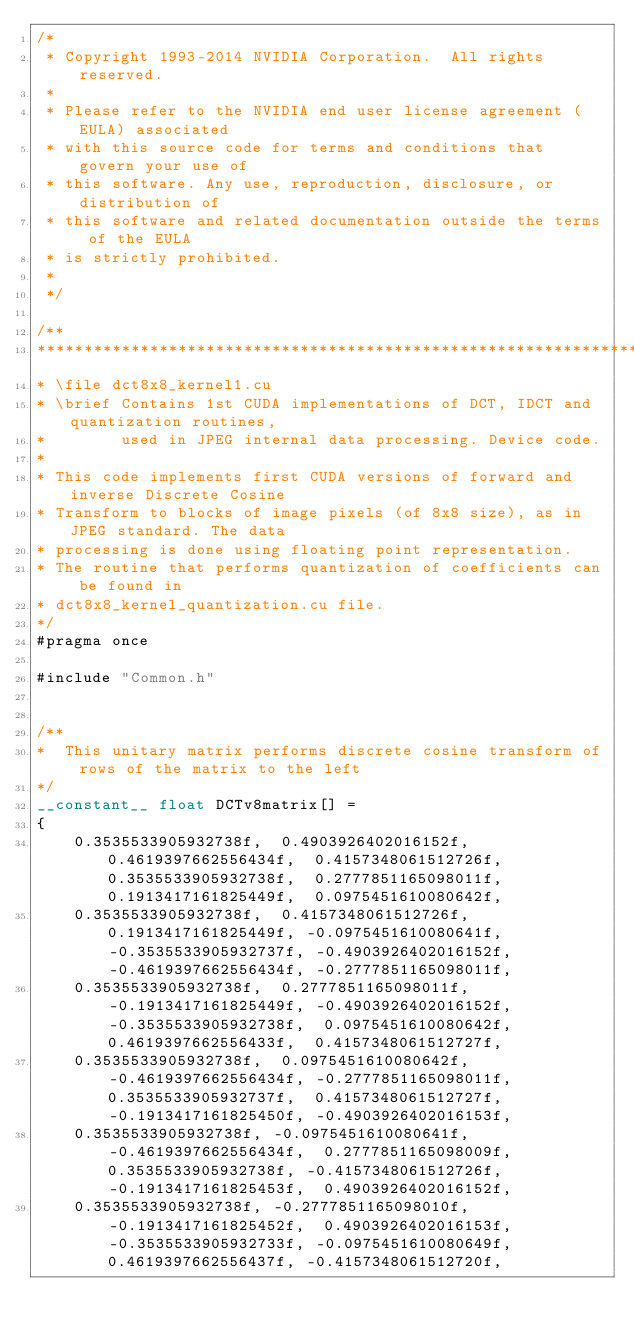<code> <loc_0><loc_0><loc_500><loc_500><_Cuda_>/*
 * Copyright 1993-2014 NVIDIA Corporation.  All rights reserved.
 *
 * Please refer to the NVIDIA end user license agreement (EULA) associated
 * with this source code for terms and conditions that govern your use of
 * this software. Any use, reproduction, disclosure, or distribution of
 * this software and related documentation outside the terms of the EULA
 * is strictly prohibited.
 *
 */

/**
**************************************************************************
* \file dct8x8_kernel1.cu
* \brief Contains 1st CUDA implementations of DCT, IDCT and quantization routines,
*        used in JPEG internal data processing. Device code.
*
* This code implements first CUDA versions of forward and inverse Discrete Cosine
* Transform to blocks of image pixels (of 8x8 size), as in JPEG standard. The data
* processing is done using floating point representation.
* The routine that performs quantization of coefficients can be found in
* dct8x8_kernel_quantization.cu file.
*/
#pragma once

#include "Common.h"


/**
*  This unitary matrix performs discrete cosine transform of rows of the matrix to the left
*/
__constant__ float DCTv8matrix[] =
{
    0.3535533905932738f,  0.4903926402016152f,  0.4619397662556434f,  0.4157348061512726f,  0.3535533905932738f,  0.2777851165098011f,  0.1913417161825449f,  0.0975451610080642f,
    0.3535533905932738f,  0.4157348061512726f,  0.1913417161825449f, -0.0975451610080641f, -0.3535533905932737f, -0.4903926402016152f, -0.4619397662556434f, -0.2777851165098011f,
    0.3535533905932738f,  0.2777851165098011f, -0.1913417161825449f, -0.4903926402016152f, -0.3535533905932738f,  0.0975451610080642f,  0.4619397662556433f,  0.4157348061512727f,
    0.3535533905932738f,  0.0975451610080642f, -0.4619397662556434f, -0.2777851165098011f,  0.3535533905932737f,  0.4157348061512727f, -0.1913417161825450f, -0.4903926402016153f,
    0.3535533905932738f, -0.0975451610080641f, -0.4619397662556434f,  0.2777851165098009f,  0.3535533905932738f, -0.4157348061512726f, -0.1913417161825453f,  0.4903926402016152f,
    0.3535533905932738f, -0.2777851165098010f, -0.1913417161825452f,  0.4903926402016153f, -0.3535533905932733f, -0.0975451610080649f,  0.4619397662556437f, -0.4157348061512720f,</code> 